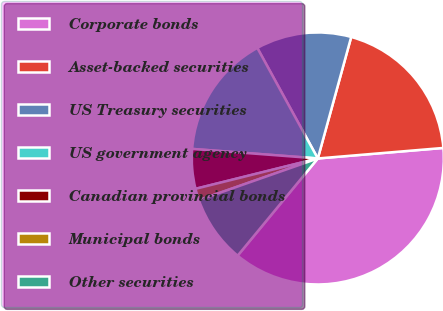Convert chart to OTSL. <chart><loc_0><loc_0><loc_500><loc_500><pie_chart><fcel>Corporate bonds<fcel>Asset-backed securities<fcel>US Treasury securities<fcel>US government agency<fcel>Canadian provincial bonds<fcel>Municipal bonds<fcel>Other securities<nl><fcel>37.31%<fcel>19.4%<fcel>12.24%<fcel>15.82%<fcel>5.08%<fcel>1.49%<fcel>8.66%<nl></chart> 